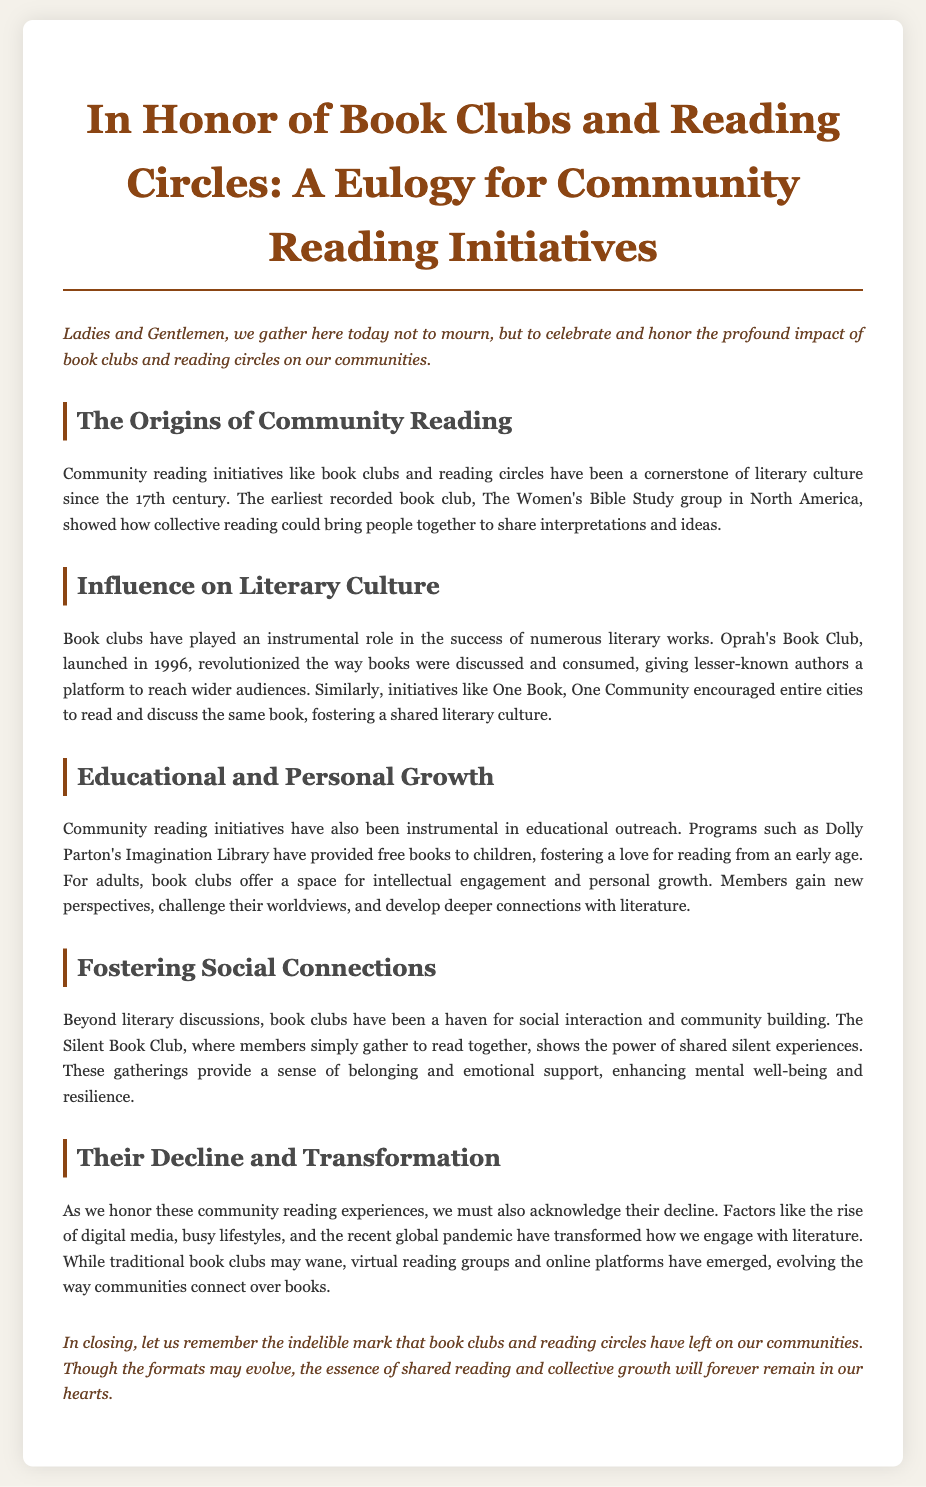What is the title of the document? The title is given at the top of the document, which introduces the main topic.
Answer: In Honor of Book Clubs and Reading Circles: A Eulogy for Community Reading Initiatives When did Oprah's Book Club launch? The document mentions the specific year Oprah's Book Club started, which is noted as a significant date in its influence.
Answer: 1996 What is the purpose of Dolly Parton's Imagination Library? The document describes educational programs and highlights this initiative's role in providing free books.
Answer: To provide free books to children What social benefit do book clubs provide according to the document? The document explains how book clubs aid in emotional support and social connection, which emphasizes their role in community building.
Answer: A sense of belonging What has transformed community reading engagement recently? The document discusses various factors that have influenced the way reading initiatives are approached in modern times.
Answer: Digital media and the pandemic 